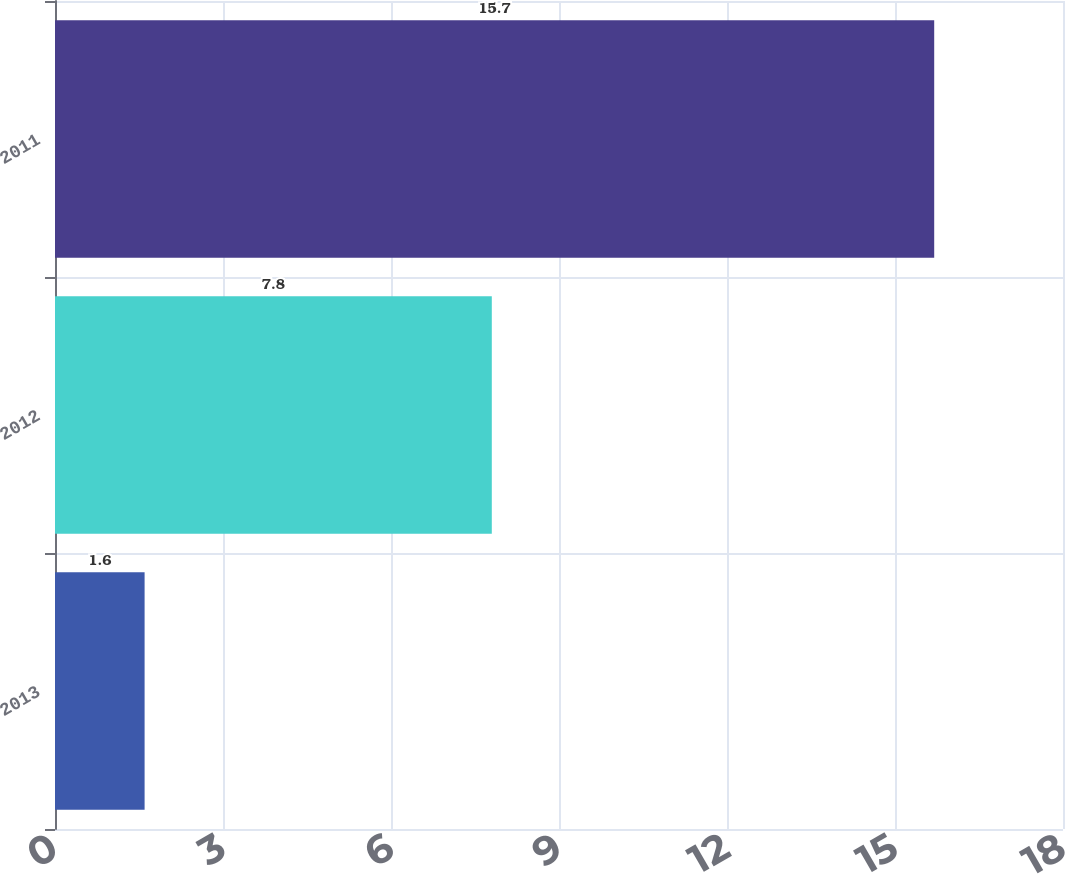<chart> <loc_0><loc_0><loc_500><loc_500><bar_chart><fcel>2013<fcel>2012<fcel>2011<nl><fcel>1.6<fcel>7.8<fcel>15.7<nl></chart> 